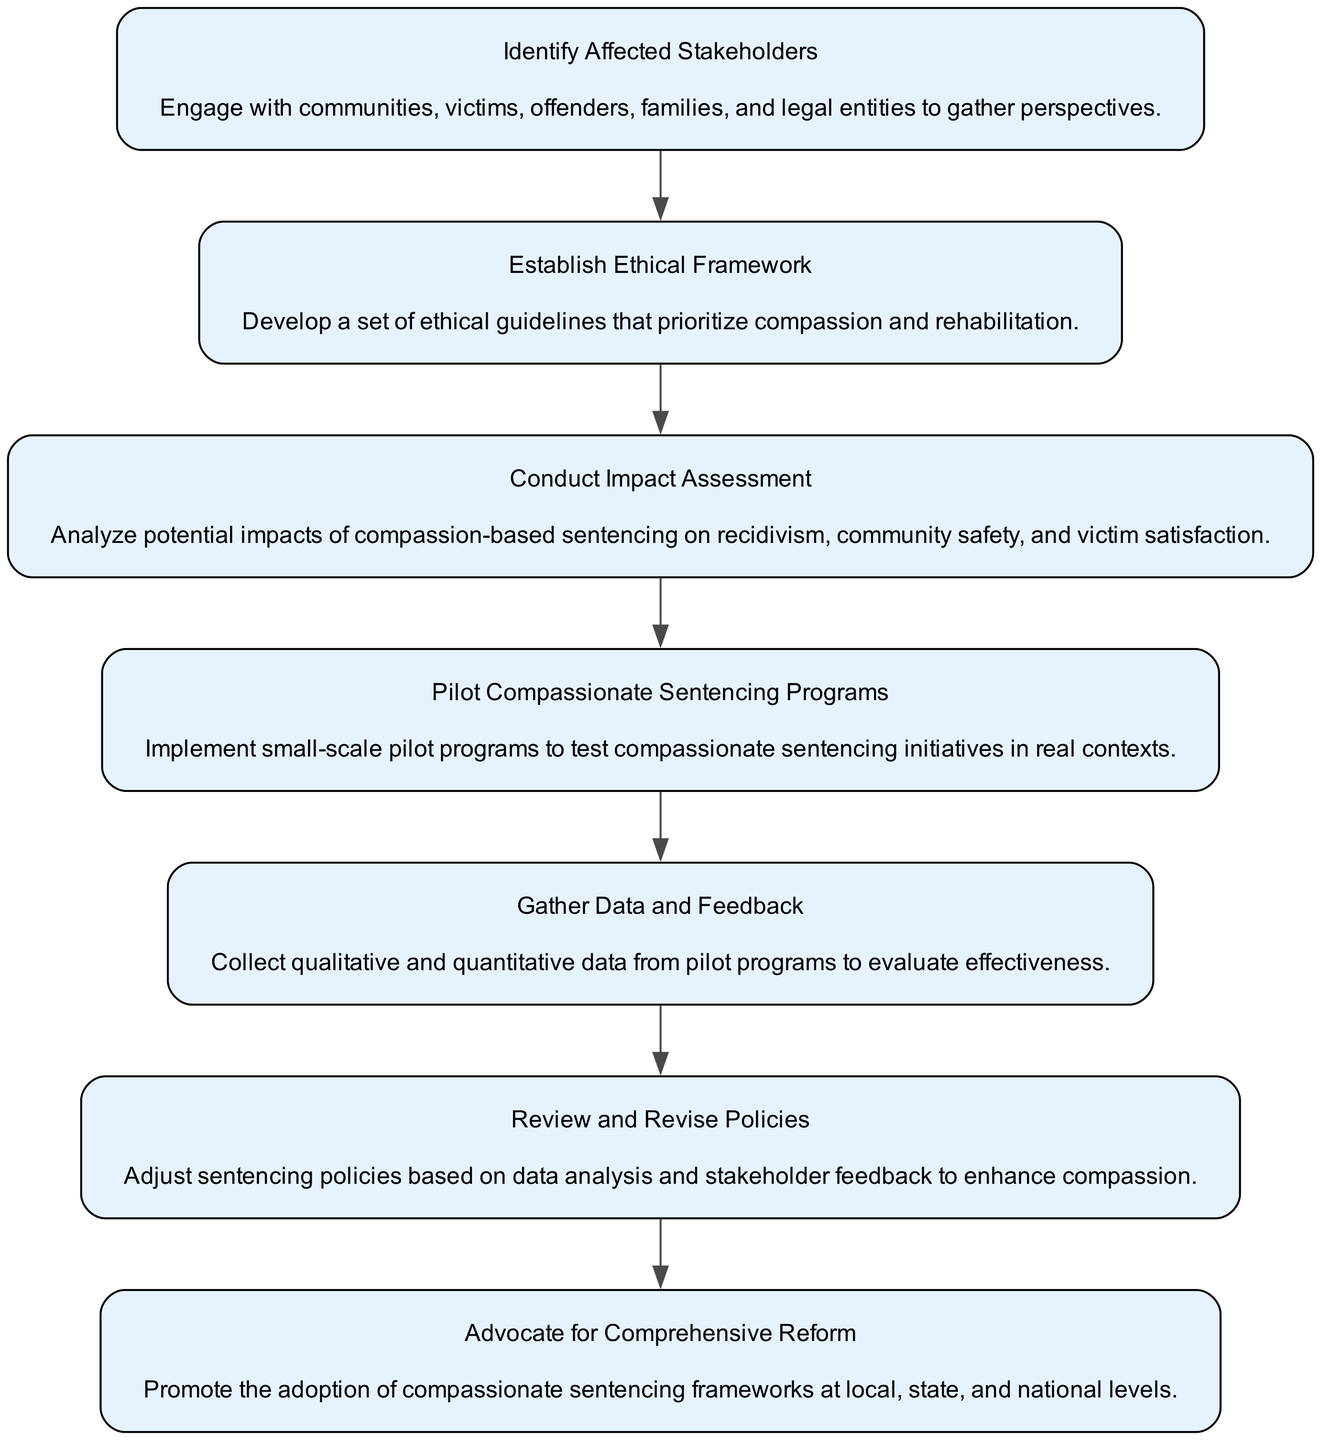What is the first step in the process? The diagram starts with the node labeled "Identify Affected Stakeholders," indicating that it is the first step in developing a compassionate sentencing framework.
Answer: Identify Affected Stakeholders How many nodes are there in total? Counting each step in the diagram from "Identify Affected Stakeholders" to "Advocate for Comprehensive Reform," there are seven nodes.
Answer: 7 What does the second node emphasize? The second node is "Establish Ethical Framework," which emphasizes developing ethical guidelines that prioritize compassion and rehabilitation.
Answer: Establish Ethical Framework Which step comes after conducting an impact assessment? The flow following "Conduct Impact Assessment" leads to "Pilot Compassionate Sentencing Programs," indicating it is the next step in the process.
Answer: Pilot Compassionate Sentencing Programs What is the final action in the framework? The last node, "Advocate for Comprehensive Reform," represents the final action to promote the adoption of compassionate sentencing at various levels.
Answer: Advocate for Comprehensive Reform What do the nodes from the first to third steps collectively focus on? The first three nodes focus on stakeholder engagement, ethical guidelines, and impact assessment, collectively emphasizing the foundational aspects of a compassionate sentencing framework.
Answer: Stakeholder engagement, ethical guidelines, and impact assessment Which node provides feedback mechanisms for the framework? The node "Gather Data and Feedback" pertains to collecting qualitative and quantitative data from pilot programs, serving as the feedback mechanism for the framework.
Answer: Gather Data and Feedback How are adjustments in policies addressed in the diagram? The node "Review and Revise Policies" specifically indicates that the adjustments to sentencing policies are made based on data analysis and stakeholder feedback.
Answer: Review and Revise Policies What is the main goal of the compassionate sentencing framework represented in the last step? The main goal in the last step, "Advocate for Comprehensive Reform," is promoting compassionate sentencing frameworks across various jurisdictions.
Answer: Promote compassionate sentencing frameworks 